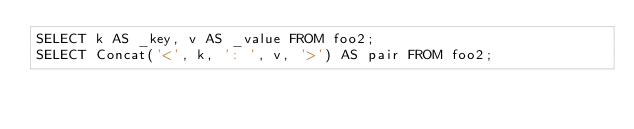Convert code to text. <code><loc_0><loc_0><loc_500><loc_500><_SQL_>SELECT k AS _key, v AS _value FROM foo2;
SELECT Concat('<', k, ': ', v, '>') AS pair FROM foo2;
</code> 